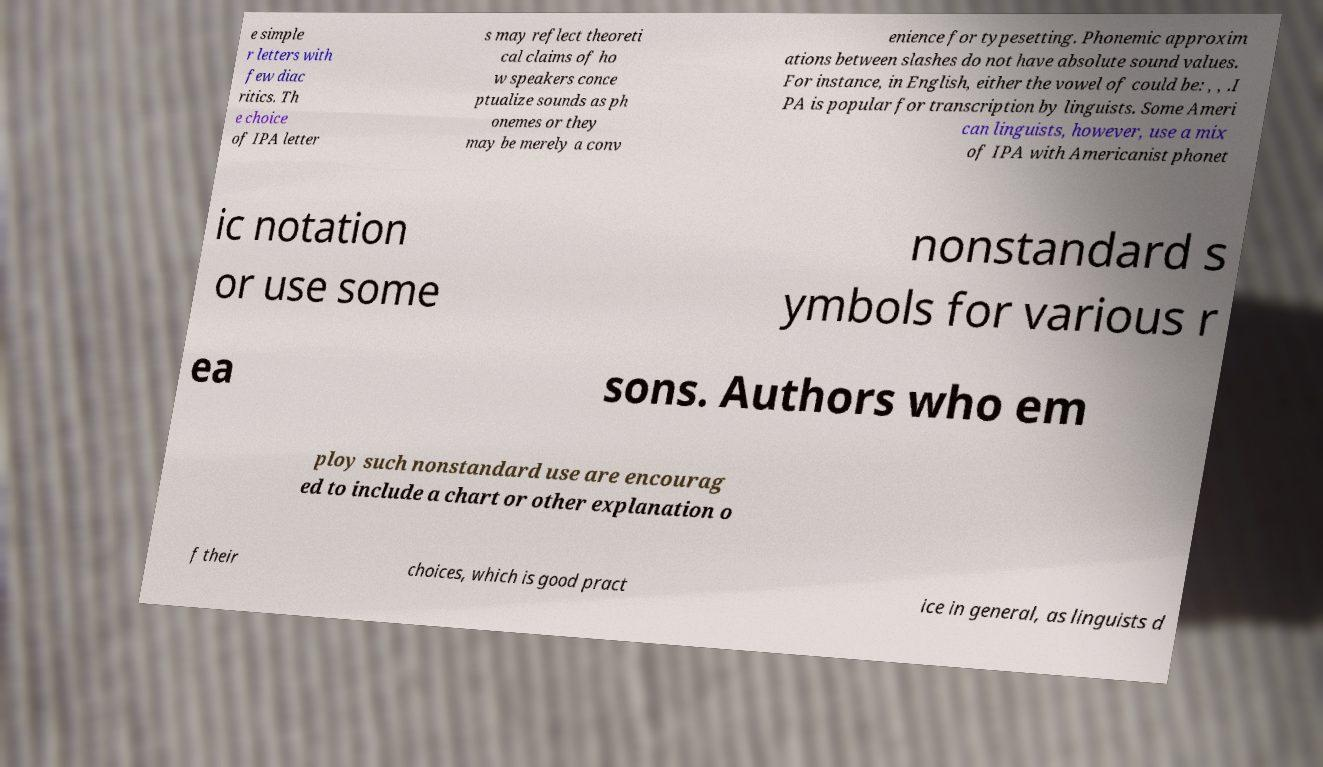There's text embedded in this image that I need extracted. Can you transcribe it verbatim? e simple r letters with few diac ritics. Th e choice of IPA letter s may reflect theoreti cal claims of ho w speakers conce ptualize sounds as ph onemes or they may be merely a conv enience for typesetting. Phonemic approxim ations between slashes do not have absolute sound values. For instance, in English, either the vowel of could be: , , .I PA is popular for transcription by linguists. Some Ameri can linguists, however, use a mix of IPA with Americanist phonet ic notation or use some nonstandard s ymbols for various r ea sons. Authors who em ploy such nonstandard use are encourag ed to include a chart or other explanation o f their choices, which is good pract ice in general, as linguists d 